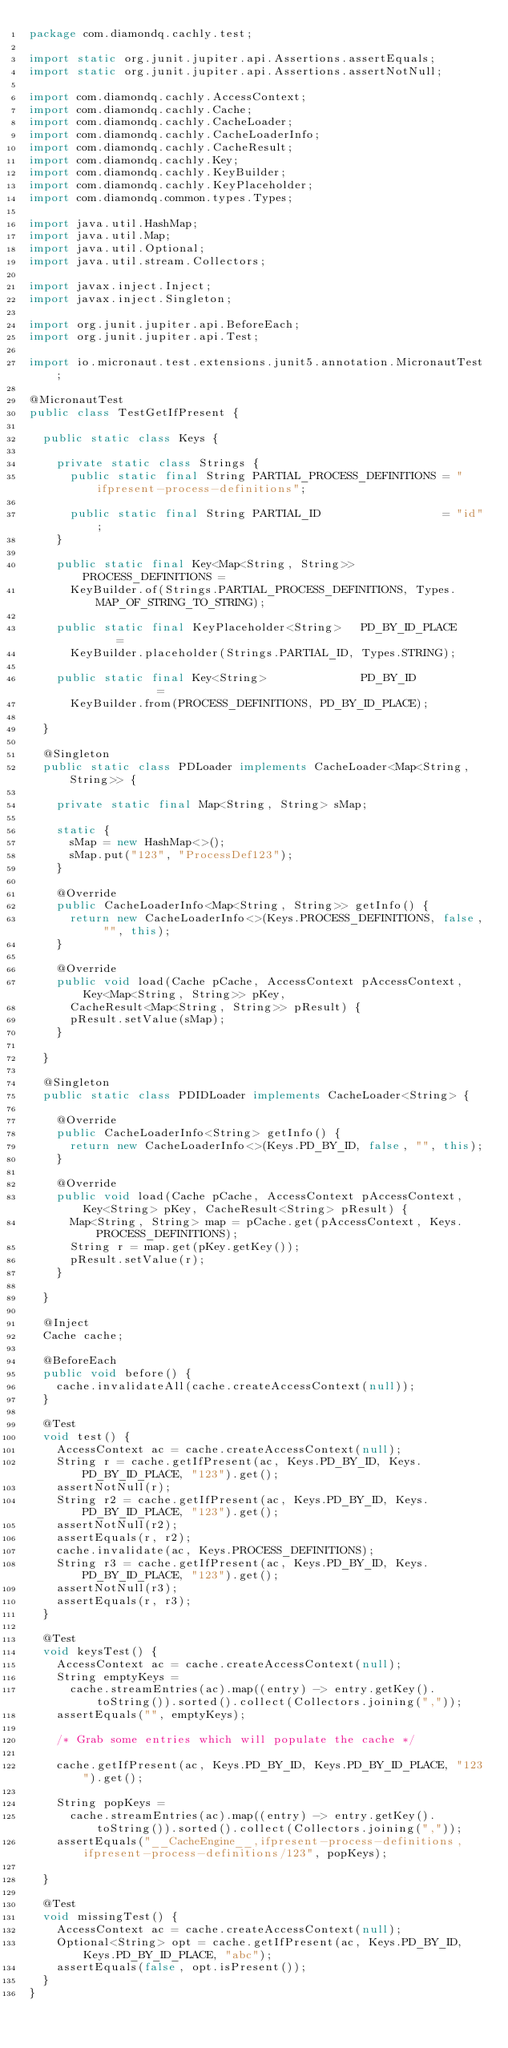<code> <loc_0><loc_0><loc_500><loc_500><_Java_>package com.diamondq.cachly.test;

import static org.junit.jupiter.api.Assertions.assertEquals;
import static org.junit.jupiter.api.Assertions.assertNotNull;

import com.diamondq.cachly.AccessContext;
import com.diamondq.cachly.Cache;
import com.diamondq.cachly.CacheLoader;
import com.diamondq.cachly.CacheLoaderInfo;
import com.diamondq.cachly.CacheResult;
import com.diamondq.cachly.Key;
import com.diamondq.cachly.KeyBuilder;
import com.diamondq.cachly.KeyPlaceholder;
import com.diamondq.common.types.Types;

import java.util.HashMap;
import java.util.Map;
import java.util.Optional;
import java.util.stream.Collectors;

import javax.inject.Inject;
import javax.inject.Singleton;

import org.junit.jupiter.api.BeforeEach;
import org.junit.jupiter.api.Test;

import io.micronaut.test.extensions.junit5.annotation.MicronautTest;

@MicronautTest
public class TestGetIfPresent {

  public static class Keys {

    private static class Strings {
      public static final String PARTIAL_PROCESS_DEFINITIONS = "ifpresent-process-definitions";

      public static final String PARTIAL_ID                  = "id";
    }

    public static final Key<Map<String, String>> PROCESS_DEFINITIONS =
      KeyBuilder.of(Strings.PARTIAL_PROCESS_DEFINITIONS, Types.MAP_OF_STRING_TO_STRING);

    public static final KeyPlaceholder<String>   PD_BY_ID_PLACE      =
      KeyBuilder.placeholder(Strings.PARTIAL_ID, Types.STRING);

    public static final Key<String>              PD_BY_ID            =
      KeyBuilder.from(PROCESS_DEFINITIONS, PD_BY_ID_PLACE);

  }

  @Singleton
  public static class PDLoader implements CacheLoader<Map<String, String>> {

    private static final Map<String, String> sMap;

    static {
      sMap = new HashMap<>();
      sMap.put("123", "ProcessDef123");
    }

    @Override
    public CacheLoaderInfo<Map<String, String>> getInfo() {
      return new CacheLoaderInfo<>(Keys.PROCESS_DEFINITIONS, false, "", this);
    }

    @Override
    public void load(Cache pCache, AccessContext pAccessContext, Key<Map<String, String>> pKey,
      CacheResult<Map<String, String>> pResult) {
      pResult.setValue(sMap);
    }

  }

  @Singleton
  public static class PDIDLoader implements CacheLoader<String> {

    @Override
    public CacheLoaderInfo<String> getInfo() {
      return new CacheLoaderInfo<>(Keys.PD_BY_ID, false, "", this);
    }

    @Override
    public void load(Cache pCache, AccessContext pAccessContext, Key<String> pKey, CacheResult<String> pResult) {
      Map<String, String> map = pCache.get(pAccessContext, Keys.PROCESS_DEFINITIONS);
      String r = map.get(pKey.getKey());
      pResult.setValue(r);
    }

  }

  @Inject
  Cache cache;

  @BeforeEach
  public void before() {
    cache.invalidateAll(cache.createAccessContext(null));
  }

  @Test
  void test() {
    AccessContext ac = cache.createAccessContext(null);
    String r = cache.getIfPresent(ac, Keys.PD_BY_ID, Keys.PD_BY_ID_PLACE, "123").get();
    assertNotNull(r);
    String r2 = cache.getIfPresent(ac, Keys.PD_BY_ID, Keys.PD_BY_ID_PLACE, "123").get();
    assertNotNull(r2);
    assertEquals(r, r2);
    cache.invalidate(ac, Keys.PROCESS_DEFINITIONS);
    String r3 = cache.getIfPresent(ac, Keys.PD_BY_ID, Keys.PD_BY_ID_PLACE, "123").get();
    assertNotNull(r3);
    assertEquals(r, r3);
  }

  @Test
  void keysTest() {
    AccessContext ac = cache.createAccessContext(null);
    String emptyKeys =
      cache.streamEntries(ac).map((entry) -> entry.getKey().toString()).sorted().collect(Collectors.joining(","));
    assertEquals("", emptyKeys);

    /* Grab some entries which will populate the cache */

    cache.getIfPresent(ac, Keys.PD_BY_ID, Keys.PD_BY_ID_PLACE, "123").get();

    String popKeys =
      cache.streamEntries(ac).map((entry) -> entry.getKey().toString()).sorted().collect(Collectors.joining(","));
    assertEquals("__CacheEngine__,ifpresent-process-definitions,ifpresent-process-definitions/123", popKeys);

  }

  @Test
  void missingTest() {
    AccessContext ac = cache.createAccessContext(null);
    Optional<String> opt = cache.getIfPresent(ac, Keys.PD_BY_ID, Keys.PD_BY_ID_PLACE, "abc");
    assertEquals(false, opt.isPresent());
  }
}
</code> 